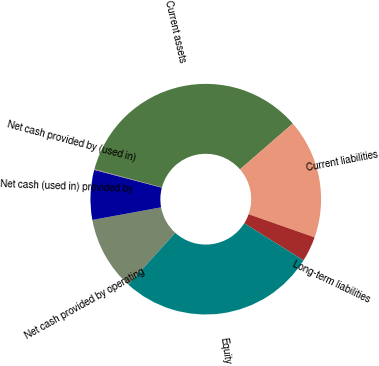Convert chart to OTSL. <chart><loc_0><loc_0><loc_500><loc_500><pie_chart><fcel>Net cash provided by operating<fcel>Net cash (used in) provided by<fcel>Net cash provided by (used in)<fcel>Current assets<fcel>Current liabilities<fcel>Long-term liabilities<fcel>Equity<nl><fcel>10.4%<fcel>6.97%<fcel>0.1%<fcel>34.42%<fcel>16.76%<fcel>3.53%<fcel>27.82%<nl></chart> 